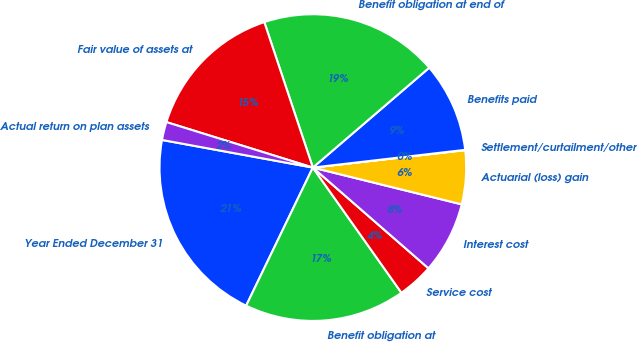Convert chart. <chart><loc_0><loc_0><loc_500><loc_500><pie_chart><fcel>Year Ended December 31<fcel>Benefit obligation at<fcel>Service cost<fcel>Interest cost<fcel>Actuarial (loss) gain<fcel>Settlement/curtailment/other<fcel>Benefits paid<fcel>Benefit obligation at end of<fcel>Fair value of assets at<fcel>Actual return on plan assets<nl><fcel>20.72%<fcel>16.96%<fcel>3.79%<fcel>7.55%<fcel>5.67%<fcel>0.03%<fcel>9.44%<fcel>18.84%<fcel>15.08%<fcel>1.91%<nl></chart> 